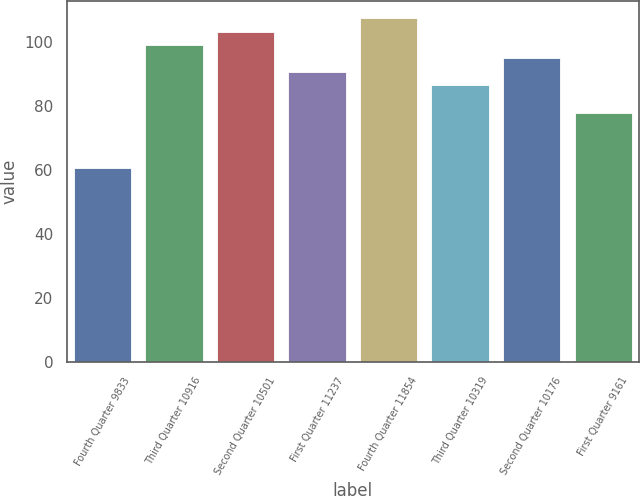Convert chart. <chart><loc_0><loc_0><loc_500><loc_500><bar_chart><fcel>Fourth Quarter 9833<fcel>Third Quarter 10916<fcel>Second Quarter 10501<fcel>First Quarter 11237<fcel>Fourth Quarter 11854<fcel>Third Quarter 10319<fcel>Second Quarter 10176<fcel>First Quarter 9161<nl><fcel>60.64<fcel>99.1<fcel>103.27<fcel>90.76<fcel>107.44<fcel>86.59<fcel>94.93<fcel>77.78<nl></chart> 